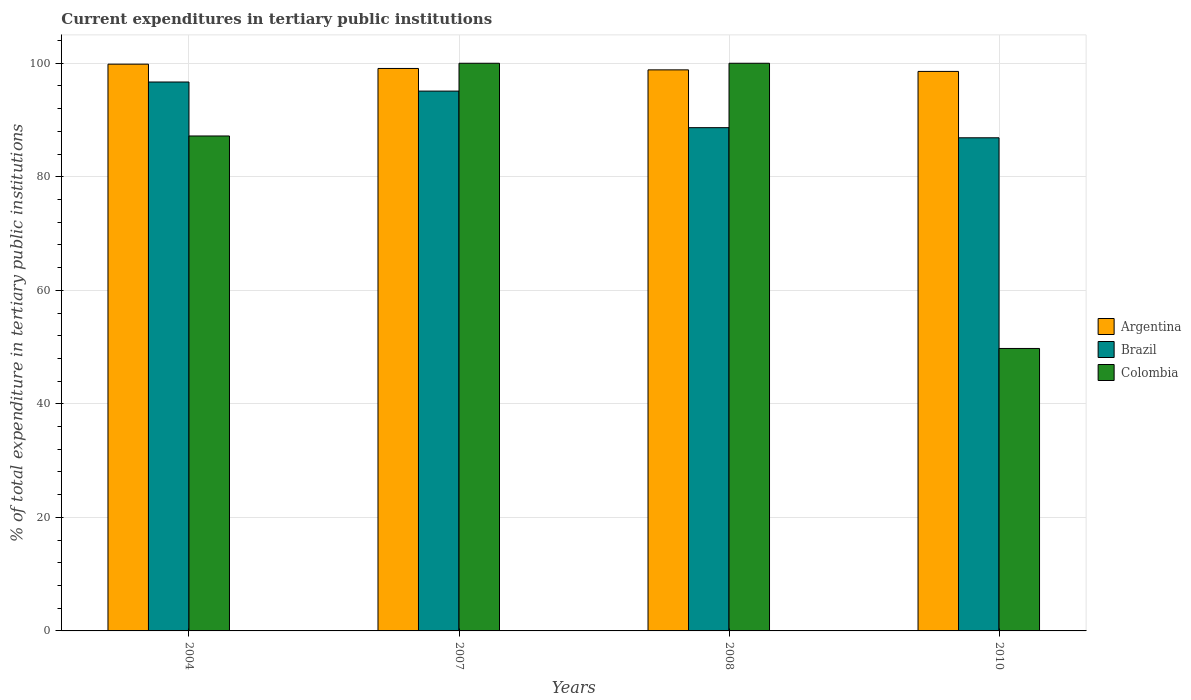How many different coloured bars are there?
Provide a short and direct response. 3. How many groups of bars are there?
Offer a very short reply. 4. Are the number of bars per tick equal to the number of legend labels?
Give a very brief answer. Yes. Are the number of bars on each tick of the X-axis equal?
Offer a very short reply. Yes. What is the label of the 2nd group of bars from the left?
Give a very brief answer. 2007. What is the current expenditures in tertiary public institutions in Colombia in 2007?
Make the answer very short. 100. Across all years, what is the maximum current expenditures in tertiary public institutions in Brazil?
Your answer should be compact. 96.7. Across all years, what is the minimum current expenditures in tertiary public institutions in Argentina?
Give a very brief answer. 98.56. In which year was the current expenditures in tertiary public institutions in Colombia maximum?
Provide a succinct answer. 2007. In which year was the current expenditures in tertiary public institutions in Brazil minimum?
Offer a terse response. 2010. What is the total current expenditures in tertiary public institutions in Brazil in the graph?
Give a very brief answer. 367.32. What is the difference between the current expenditures in tertiary public institutions in Argentina in 2007 and that in 2008?
Your answer should be very brief. 0.25. What is the difference between the current expenditures in tertiary public institutions in Colombia in 2007 and the current expenditures in tertiary public institutions in Brazil in 2008?
Provide a succinct answer. 11.35. What is the average current expenditures in tertiary public institutions in Brazil per year?
Offer a terse response. 91.83. In the year 2010, what is the difference between the current expenditures in tertiary public institutions in Colombia and current expenditures in tertiary public institutions in Argentina?
Your response must be concise. -48.8. In how many years, is the current expenditures in tertiary public institutions in Brazil greater than 36 %?
Ensure brevity in your answer.  4. What is the ratio of the current expenditures in tertiary public institutions in Colombia in 2004 to that in 2010?
Offer a terse response. 1.75. Is the current expenditures in tertiary public institutions in Colombia in 2004 less than that in 2008?
Your response must be concise. Yes. What is the difference between the highest and the second highest current expenditures in tertiary public institutions in Argentina?
Your response must be concise. 0.76. What is the difference between the highest and the lowest current expenditures in tertiary public institutions in Brazil?
Make the answer very short. 9.83. In how many years, is the current expenditures in tertiary public institutions in Colombia greater than the average current expenditures in tertiary public institutions in Colombia taken over all years?
Offer a terse response. 3. Is the sum of the current expenditures in tertiary public institutions in Brazil in 2007 and 2010 greater than the maximum current expenditures in tertiary public institutions in Colombia across all years?
Keep it short and to the point. Yes. What does the 1st bar from the left in 2010 represents?
Provide a short and direct response. Argentina. Is it the case that in every year, the sum of the current expenditures in tertiary public institutions in Colombia and current expenditures in tertiary public institutions in Argentina is greater than the current expenditures in tertiary public institutions in Brazil?
Make the answer very short. Yes. How many bars are there?
Provide a short and direct response. 12. What is the difference between two consecutive major ticks on the Y-axis?
Provide a succinct answer. 20. Does the graph contain any zero values?
Provide a short and direct response. No. Does the graph contain grids?
Give a very brief answer. Yes. Where does the legend appear in the graph?
Offer a terse response. Center right. How many legend labels are there?
Your response must be concise. 3. How are the legend labels stacked?
Make the answer very short. Vertical. What is the title of the graph?
Provide a succinct answer. Current expenditures in tertiary public institutions. What is the label or title of the Y-axis?
Provide a succinct answer. % of total expenditure in tertiary public institutions. What is the % of total expenditure in tertiary public institutions of Argentina in 2004?
Give a very brief answer. 99.84. What is the % of total expenditure in tertiary public institutions of Brazil in 2004?
Provide a short and direct response. 96.7. What is the % of total expenditure in tertiary public institutions of Colombia in 2004?
Offer a terse response. 87.19. What is the % of total expenditure in tertiary public institutions of Argentina in 2007?
Your answer should be compact. 99.08. What is the % of total expenditure in tertiary public institutions in Brazil in 2007?
Make the answer very short. 95.09. What is the % of total expenditure in tertiary public institutions in Colombia in 2007?
Keep it short and to the point. 100. What is the % of total expenditure in tertiary public institutions in Argentina in 2008?
Your answer should be very brief. 98.84. What is the % of total expenditure in tertiary public institutions of Brazil in 2008?
Keep it short and to the point. 88.65. What is the % of total expenditure in tertiary public institutions in Argentina in 2010?
Make the answer very short. 98.56. What is the % of total expenditure in tertiary public institutions in Brazil in 2010?
Your answer should be very brief. 86.87. What is the % of total expenditure in tertiary public institutions in Colombia in 2010?
Offer a terse response. 49.76. Across all years, what is the maximum % of total expenditure in tertiary public institutions of Argentina?
Provide a short and direct response. 99.84. Across all years, what is the maximum % of total expenditure in tertiary public institutions of Brazil?
Offer a terse response. 96.7. Across all years, what is the maximum % of total expenditure in tertiary public institutions of Colombia?
Your response must be concise. 100. Across all years, what is the minimum % of total expenditure in tertiary public institutions in Argentina?
Make the answer very short. 98.56. Across all years, what is the minimum % of total expenditure in tertiary public institutions of Brazil?
Ensure brevity in your answer.  86.87. Across all years, what is the minimum % of total expenditure in tertiary public institutions in Colombia?
Ensure brevity in your answer.  49.76. What is the total % of total expenditure in tertiary public institutions in Argentina in the graph?
Your answer should be compact. 396.33. What is the total % of total expenditure in tertiary public institutions of Brazil in the graph?
Keep it short and to the point. 367.32. What is the total % of total expenditure in tertiary public institutions of Colombia in the graph?
Your answer should be compact. 336.95. What is the difference between the % of total expenditure in tertiary public institutions in Argentina in 2004 and that in 2007?
Ensure brevity in your answer.  0.76. What is the difference between the % of total expenditure in tertiary public institutions of Brazil in 2004 and that in 2007?
Your answer should be very brief. 1.6. What is the difference between the % of total expenditure in tertiary public institutions of Colombia in 2004 and that in 2007?
Your answer should be compact. -12.81. What is the difference between the % of total expenditure in tertiary public institutions of Brazil in 2004 and that in 2008?
Your answer should be very brief. 8.04. What is the difference between the % of total expenditure in tertiary public institutions of Colombia in 2004 and that in 2008?
Offer a very short reply. -12.81. What is the difference between the % of total expenditure in tertiary public institutions in Argentina in 2004 and that in 2010?
Ensure brevity in your answer.  1.28. What is the difference between the % of total expenditure in tertiary public institutions of Brazil in 2004 and that in 2010?
Your answer should be compact. 9.83. What is the difference between the % of total expenditure in tertiary public institutions in Colombia in 2004 and that in 2010?
Provide a short and direct response. 37.43. What is the difference between the % of total expenditure in tertiary public institutions in Argentina in 2007 and that in 2008?
Your answer should be very brief. 0.25. What is the difference between the % of total expenditure in tertiary public institutions of Brazil in 2007 and that in 2008?
Your answer should be very brief. 6.44. What is the difference between the % of total expenditure in tertiary public institutions of Argentina in 2007 and that in 2010?
Give a very brief answer. 0.52. What is the difference between the % of total expenditure in tertiary public institutions in Brazil in 2007 and that in 2010?
Ensure brevity in your answer.  8.22. What is the difference between the % of total expenditure in tertiary public institutions of Colombia in 2007 and that in 2010?
Your response must be concise. 50.24. What is the difference between the % of total expenditure in tertiary public institutions in Argentina in 2008 and that in 2010?
Offer a very short reply. 0.27. What is the difference between the % of total expenditure in tertiary public institutions of Brazil in 2008 and that in 2010?
Your response must be concise. 1.78. What is the difference between the % of total expenditure in tertiary public institutions of Colombia in 2008 and that in 2010?
Your answer should be compact. 50.24. What is the difference between the % of total expenditure in tertiary public institutions of Argentina in 2004 and the % of total expenditure in tertiary public institutions of Brazil in 2007?
Your response must be concise. 4.75. What is the difference between the % of total expenditure in tertiary public institutions in Argentina in 2004 and the % of total expenditure in tertiary public institutions in Colombia in 2007?
Your response must be concise. -0.16. What is the difference between the % of total expenditure in tertiary public institutions of Brazil in 2004 and the % of total expenditure in tertiary public institutions of Colombia in 2007?
Make the answer very short. -3.3. What is the difference between the % of total expenditure in tertiary public institutions in Argentina in 2004 and the % of total expenditure in tertiary public institutions in Brazil in 2008?
Give a very brief answer. 11.19. What is the difference between the % of total expenditure in tertiary public institutions of Argentina in 2004 and the % of total expenditure in tertiary public institutions of Colombia in 2008?
Provide a short and direct response. -0.16. What is the difference between the % of total expenditure in tertiary public institutions of Brazil in 2004 and the % of total expenditure in tertiary public institutions of Colombia in 2008?
Ensure brevity in your answer.  -3.3. What is the difference between the % of total expenditure in tertiary public institutions of Argentina in 2004 and the % of total expenditure in tertiary public institutions of Brazil in 2010?
Keep it short and to the point. 12.97. What is the difference between the % of total expenditure in tertiary public institutions of Argentina in 2004 and the % of total expenditure in tertiary public institutions of Colombia in 2010?
Provide a short and direct response. 50.08. What is the difference between the % of total expenditure in tertiary public institutions of Brazil in 2004 and the % of total expenditure in tertiary public institutions of Colombia in 2010?
Your answer should be compact. 46.94. What is the difference between the % of total expenditure in tertiary public institutions in Argentina in 2007 and the % of total expenditure in tertiary public institutions in Brazil in 2008?
Provide a short and direct response. 10.43. What is the difference between the % of total expenditure in tertiary public institutions of Argentina in 2007 and the % of total expenditure in tertiary public institutions of Colombia in 2008?
Provide a succinct answer. -0.92. What is the difference between the % of total expenditure in tertiary public institutions of Brazil in 2007 and the % of total expenditure in tertiary public institutions of Colombia in 2008?
Your response must be concise. -4.91. What is the difference between the % of total expenditure in tertiary public institutions of Argentina in 2007 and the % of total expenditure in tertiary public institutions of Brazil in 2010?
Your response must be concise. 12.21. What is the difference between the % of total expenditure in tertiary public institutions in Argentina in 2007 and the % of total expenditure in tertiary public institutions in Colombia in 2010?
Offer a terse response. 49.32. What is the difference between the % of total expenditure in tertiary public institutions of Brazil in 2007 and the % of total expenditure in tertiary public institutions of Colombia in 2010?
Your answer should be compact. 45.33. What is the difference between the % of total expenditure in tertiary public institutions of Argentina in 2008 and the % of total expenditure in tertiary public institutions of Brazil in 2010?
Make the answer very short. 11.97. What is the difference between the % of total expenditure in tertiary public institutions in Argentina in 2008 and the % of total expenditure in tertiary public institutions in Colombia in 2010?
Ensure brevity in your answer.  49.08. What is the difference between the % of total expenditure in tertiary public institutions of Brazil in 2008 and the % of total expenditure in tertiary public institutions of Colombia in 2010?
Your answer should be compact. 38.9. What is the average % of total expenditure in tertiary public institutions of Argentina per year?
Offer a terse response. 99.08. What is the average % of total expenditure in tertiary public institutions in Brazil per year?
Offer a terse response. 91.83. What is the average % of total expenditure in tertiary public institutions of Colombia per year?
Provide a succinct answer. 84.24. In the year 2004, what is the difference between the % of total expenditure in tertiary public institutions of Argentina and % of total expenditure in tertiary public institutions of Brazil?
Provide a succinct answer. 3.14. In the year 2004, what is the difference between the % of total expenditure in tertiary public institutions in Argentina and % of total expenditure in tertiary public institutions in Colombia?
Your response must be concise. 12.65. In the year 2004, what is the difference between the % of total expenditure in tertiary public institutions in Brazil and % of total expenditure in tertiary public institutions in Colombia?
Make the answer very short. 9.51. In the year 2007, what is the difference between the % of total expenditure in tertiary public institutions of Argentina and % of total expenditure in tertiary public institutions of Brazil?
Provide a short and direct response. 3.99. In the year 2007, what is the difference between the % of total expenditure in tertiary public institutions in Argentina and % of total expenditure in tertiary public institutions in Colombia?
Ensure brevity in your answer.  -0.92. In the year 2007, what is the difference between the % of total expenditure in tertiary public institutions in Brazil and % of total expenditure in tertiary public institutions in Colombia?
Keep it short and to the point. -4.91. In the year 2008, what is the difference between the % of total expenditure in tertiary public institutions in Argentina and % of total expenditure in tertiary public institutions in Brazil?
Offer a terse response. 10.18. In the year 2008, what is the difference between the % of total expenditure in tertiary public institutions in Argentina and % of total expenditure in tertiary public institutions in Colombia?
Your answer should be compact. -1.16. In the year 2008, what is the difference between the % of total expenditure in tertiary public institutions in Brazil and % of total expenditure in tertiary public institutions in Colombia?
Your response must be concise. -11.35. In the year 2010, what is the difference between the % of total expenditure in tertiary public institutions of Argentina and % of total expenditure in tertiary public institutions of Brazil?
Give a very brief answer. 11.69. In the year 2010, what is the difference between the % of total expenditure in tertiary public institutions of Argentina and % of total expenditure in tertiary public institutions of Colombia?
Give a very brief answer. 48.8. In the year 2010, what is the difference between the % of total expenditure in tertiary public institutions of Brazil and % of total expenditure in tertiary public institutions of Colombia?
Give a very brief answer. 37.11. What is the ratio of the % of total expenditure in tertiary public institutions in Argentina in 2004 to that in 2007?
Provide a short and direct response. 1.01. What is the ratio of the % of total expenditure in tertiary public institutions in Brazil in 2004 to that in 2007?
Keep it short and to the point. 1.02. What is the ratio of the % of total expenditure in tertiary public institutions in Colombia in 2004 to that in 2007?
Your answer should be compact. 0.87. What is the ratio of the % of total expenditure in tertiary public institutions of Argentina in 2004 to that in 2008?
Keep it short and to the point. 1.01. What is the ratio of the % of total expenditure in tertiary public institutions in Brazil in 2004 to that in 2008?
Your response must be concise. 1.09. What is the ratio of the % of total expenditure in tertiary public institutions in Colombia in 2004 to that in 2008?
Make the answer very short. 0.87. What is the ratio of the % of total expenditure in tertiary public institutions in Argentina in 2004 to that in 2010?
Ensure brevity in your answer.  1.01. What is the ratio of the % of total expenditure in tertiary public institutions in Brazil in 2004 to that in 2010?
Offer a terse response. 1.11. What is the ratio of the % of total expenditure in tertiary public institutions of Colombia in 2004 to that in 2010?
Provide a succinct answer. 1.75. What is the ratio of the % of total expenditure in tertiary public institutions of Argentina in 2007 to that in 2008?
Provide a short and direct response. 1. What is the ratio of the % of total expenditure in tertiary public institutions of Brazil in 2007 to that in 2008?
Give a very brief answer. 1.07. What is the ratio of the % of total expenditure in tertiary public institutions in Brazil in 2007 to that in 2010?
Offer a terse response. 1.09. What is the ratio of the % of total expenditure in tertiary public institutions of Colombia in 2007 to that in 2010?
Your answer should be very brief. 2.01. What is the ratio of the % of total expenditure in tertiary public institutions of Argentina in 2008 to that in 2010?
Provide a short and direct response. 1. What is the ratio of the % of total expenditure in tertiary public institutions in Brazil in 2008 to that in 2010?
Offer a terse response. 1.02. What is the ratio of the % of total expenditure in tertiary public institutions in Colombia in 2008 to that in 2010?
Keep it short and to the point. 2.01. What is the difference between the highest and the second highest % of total expenditure in tertiary public institutions of Argentina?
Make the answer very short. 0.76. What is the difference between the highest and the second highest % of total expenditure in tertiary public institutions in Brazil?
Provide a short and direct response. 1.6. What is the difference between the highest and the second highest % of total expenditure in tertiary public institutions of Colombia?
Make the answer very short. 0. What is the difference between the highest and the lowest % of total expenditure in tertiary public institutions of Argentina?
Provide a short and direct response. 1.28. What is the difference between the highest and the lowest % of total expenditure in tertiary public institutions of Brazil?
Your answer should be very brief. 9.83. What is the difference between the highest and the lowest % of total expenditure in tertiary public institutions of Colombia?
Provide a short and direct response. 50.24. 